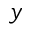<formula> <loc_0><loc_0><loc_500><loc_500>y</formula> 